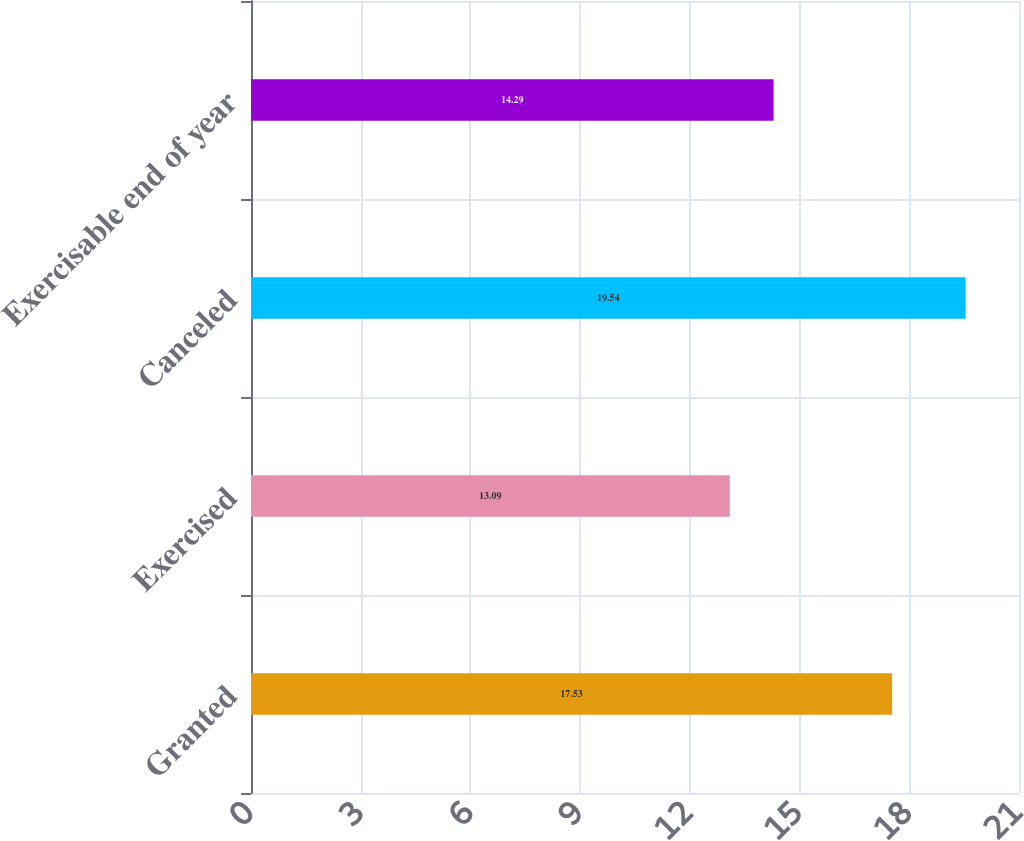<chart> <loc_0><loc_0><loc_500><loc_500><bar_chart><fcel>Granted<fcel>Exercised<fcel>Canceled<fcel>Exercisable end of year<nl><fcel>17.53<fcel>13.09<fcel>19.54<fcel>14.29<nl></chart> 